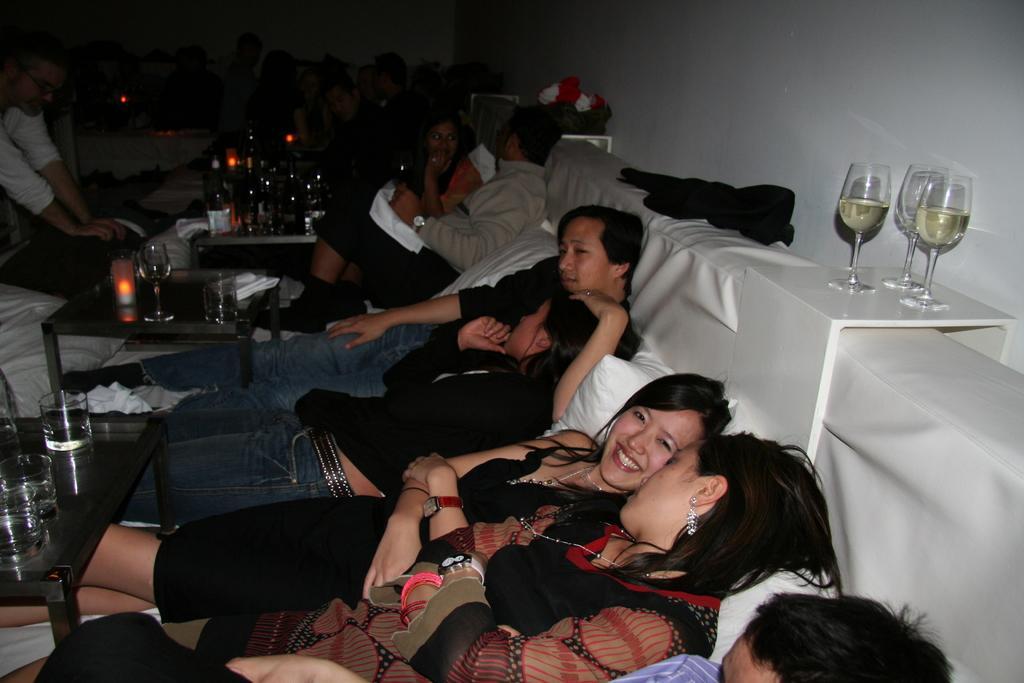How would you summarize this image in a sentence or two? This picture describe about the a group of boys and girls relaxing on the big sofa, In front we can see a wooden table on which candle light and water glasses are placed. Behind we can see the four glasses and white wall. 